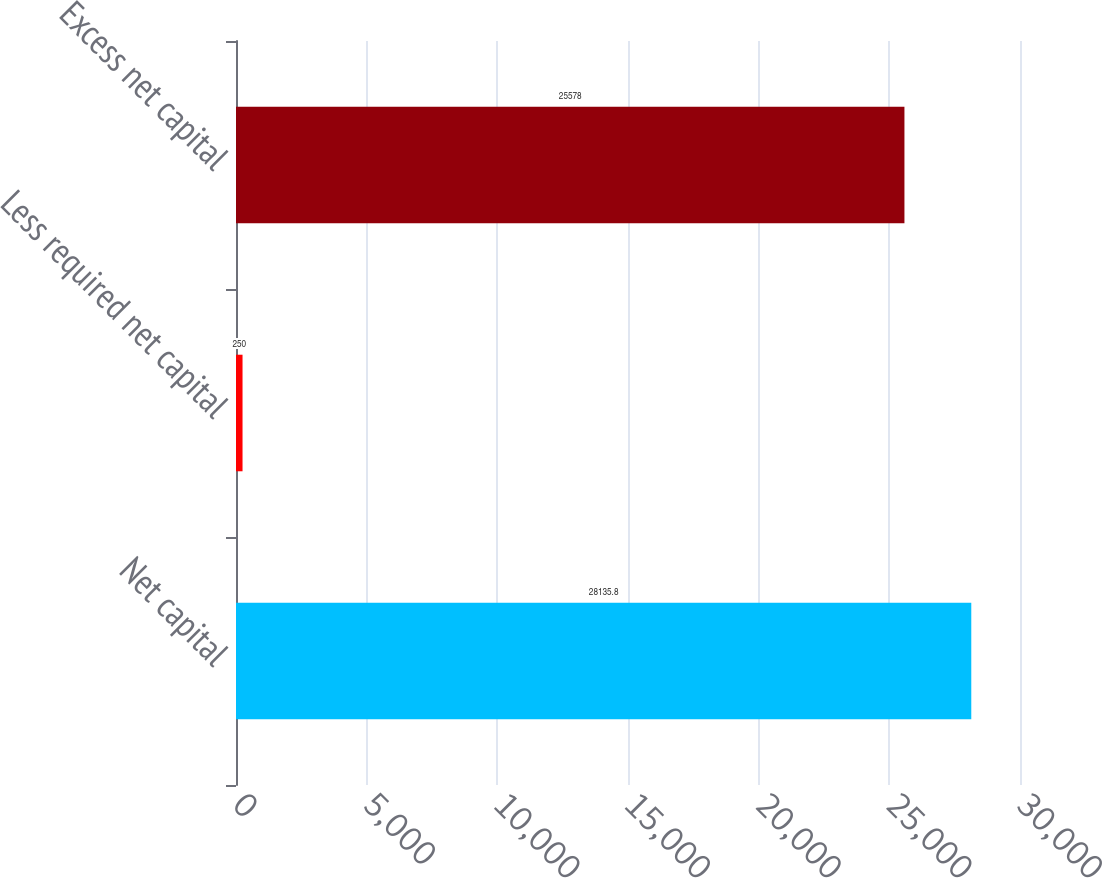<chart> <loc_0><loc_0><loc_500><loc_500><bar_chart><fcel>Net capital<fcel>Less required net capital<fcel>Excess net capital<nl><fcel>28135.8<fcel>250<fcel>25578<nl></chart> 